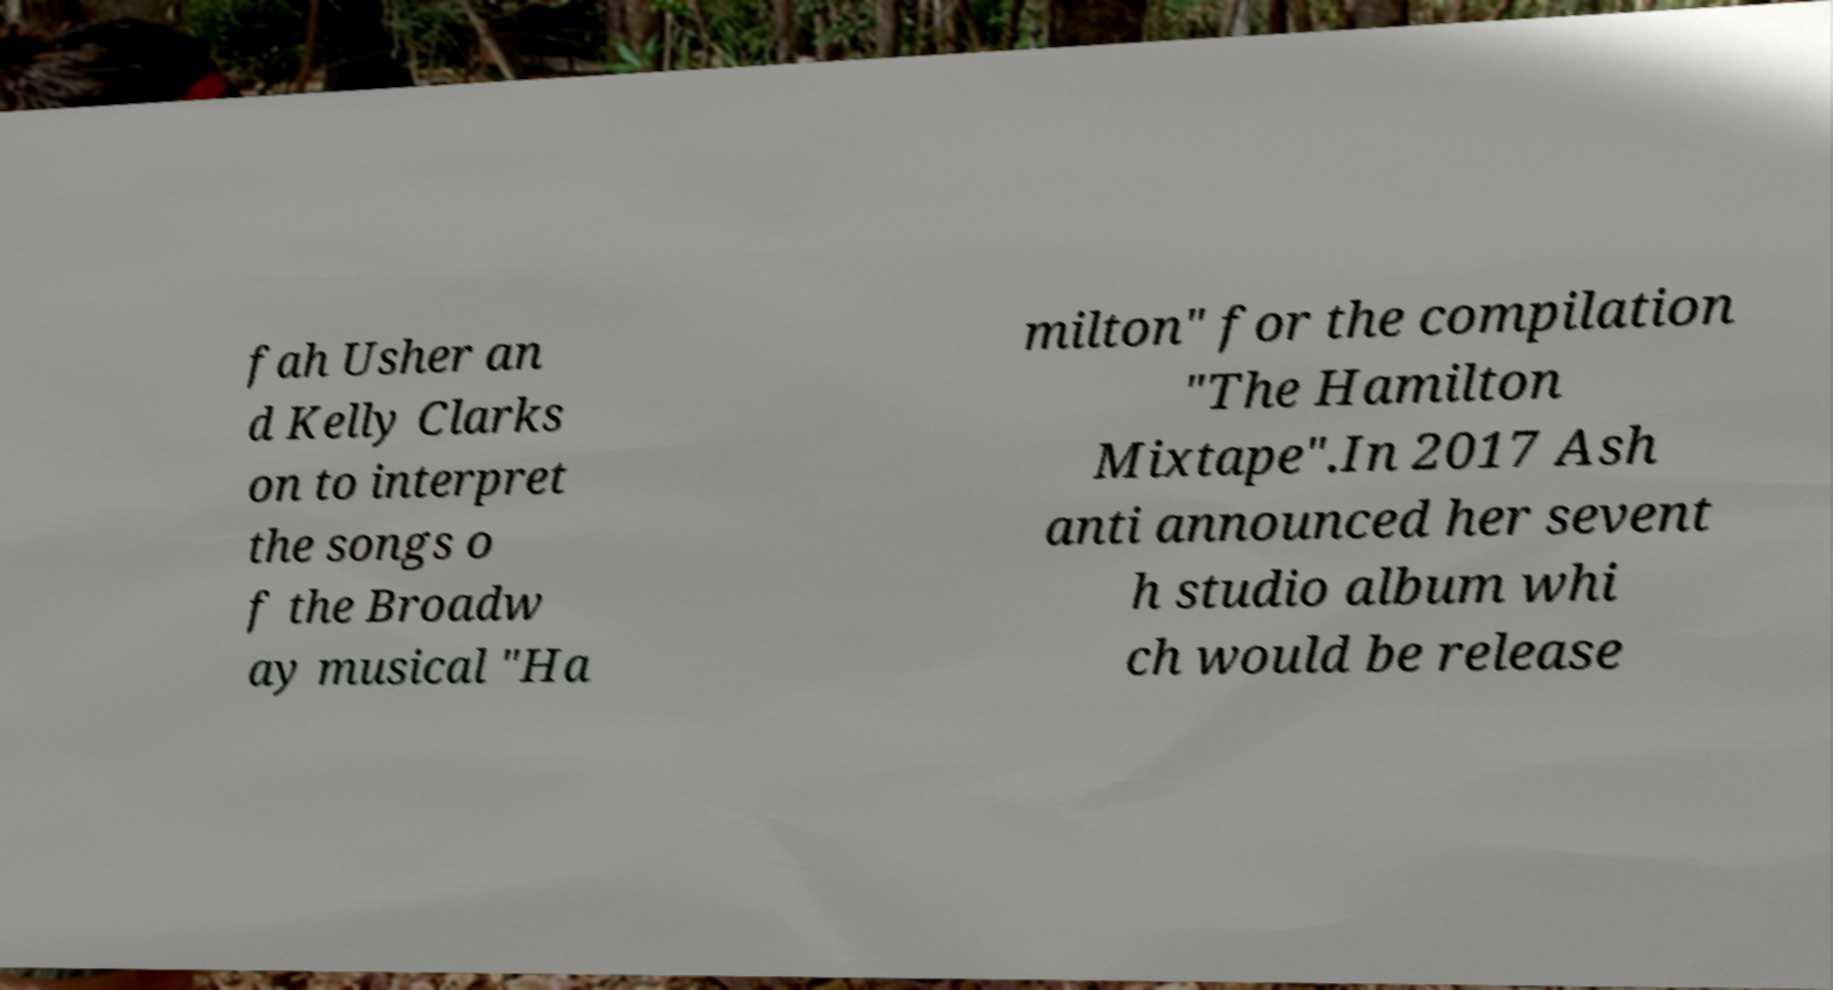Please read and relay the text visible in this image. What does it say? fah Usher an d Kelly Clarks on to interpret the songs o f the Broadw ay musical "Ha milton" for the compilation "The Hamilton Mixtape".In 2017 Ash anti announced her sevent h studio album whi ch would be release 